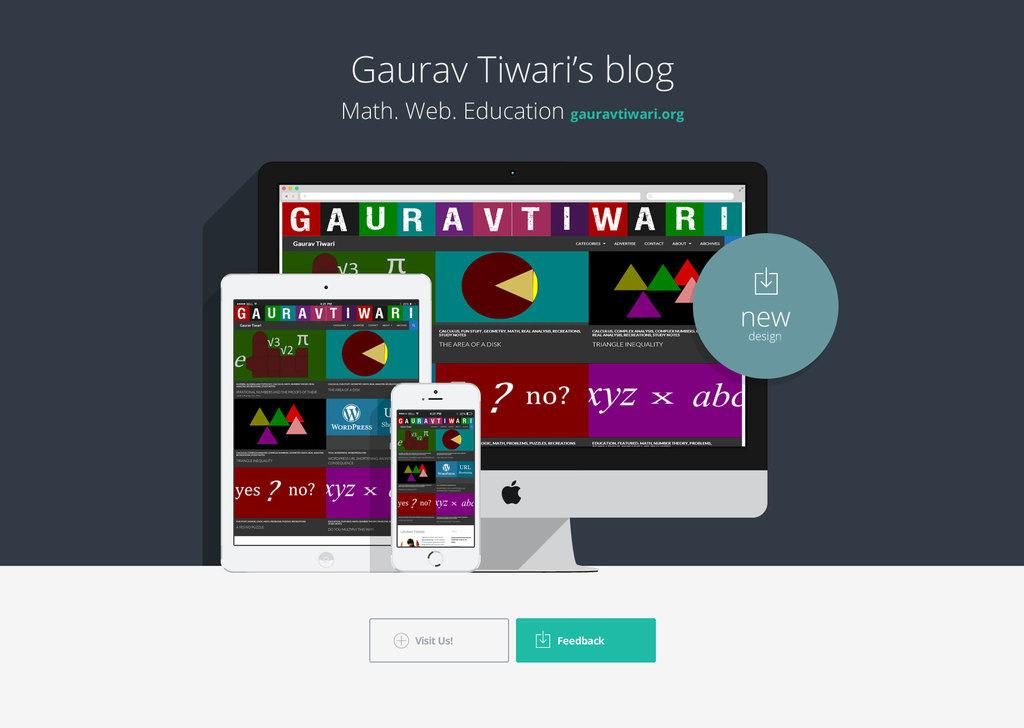<image>
Relay a brief, clear account of the picture shown. A screen shot of Guarav Tiwari's educational blog. 